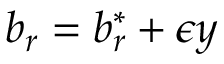Convert formula to latex. <formula><loc_0><loc_0><loc_500><loc_500>b _ { r } = b _ { r } ^ { * } + \epsilon y</formula> 